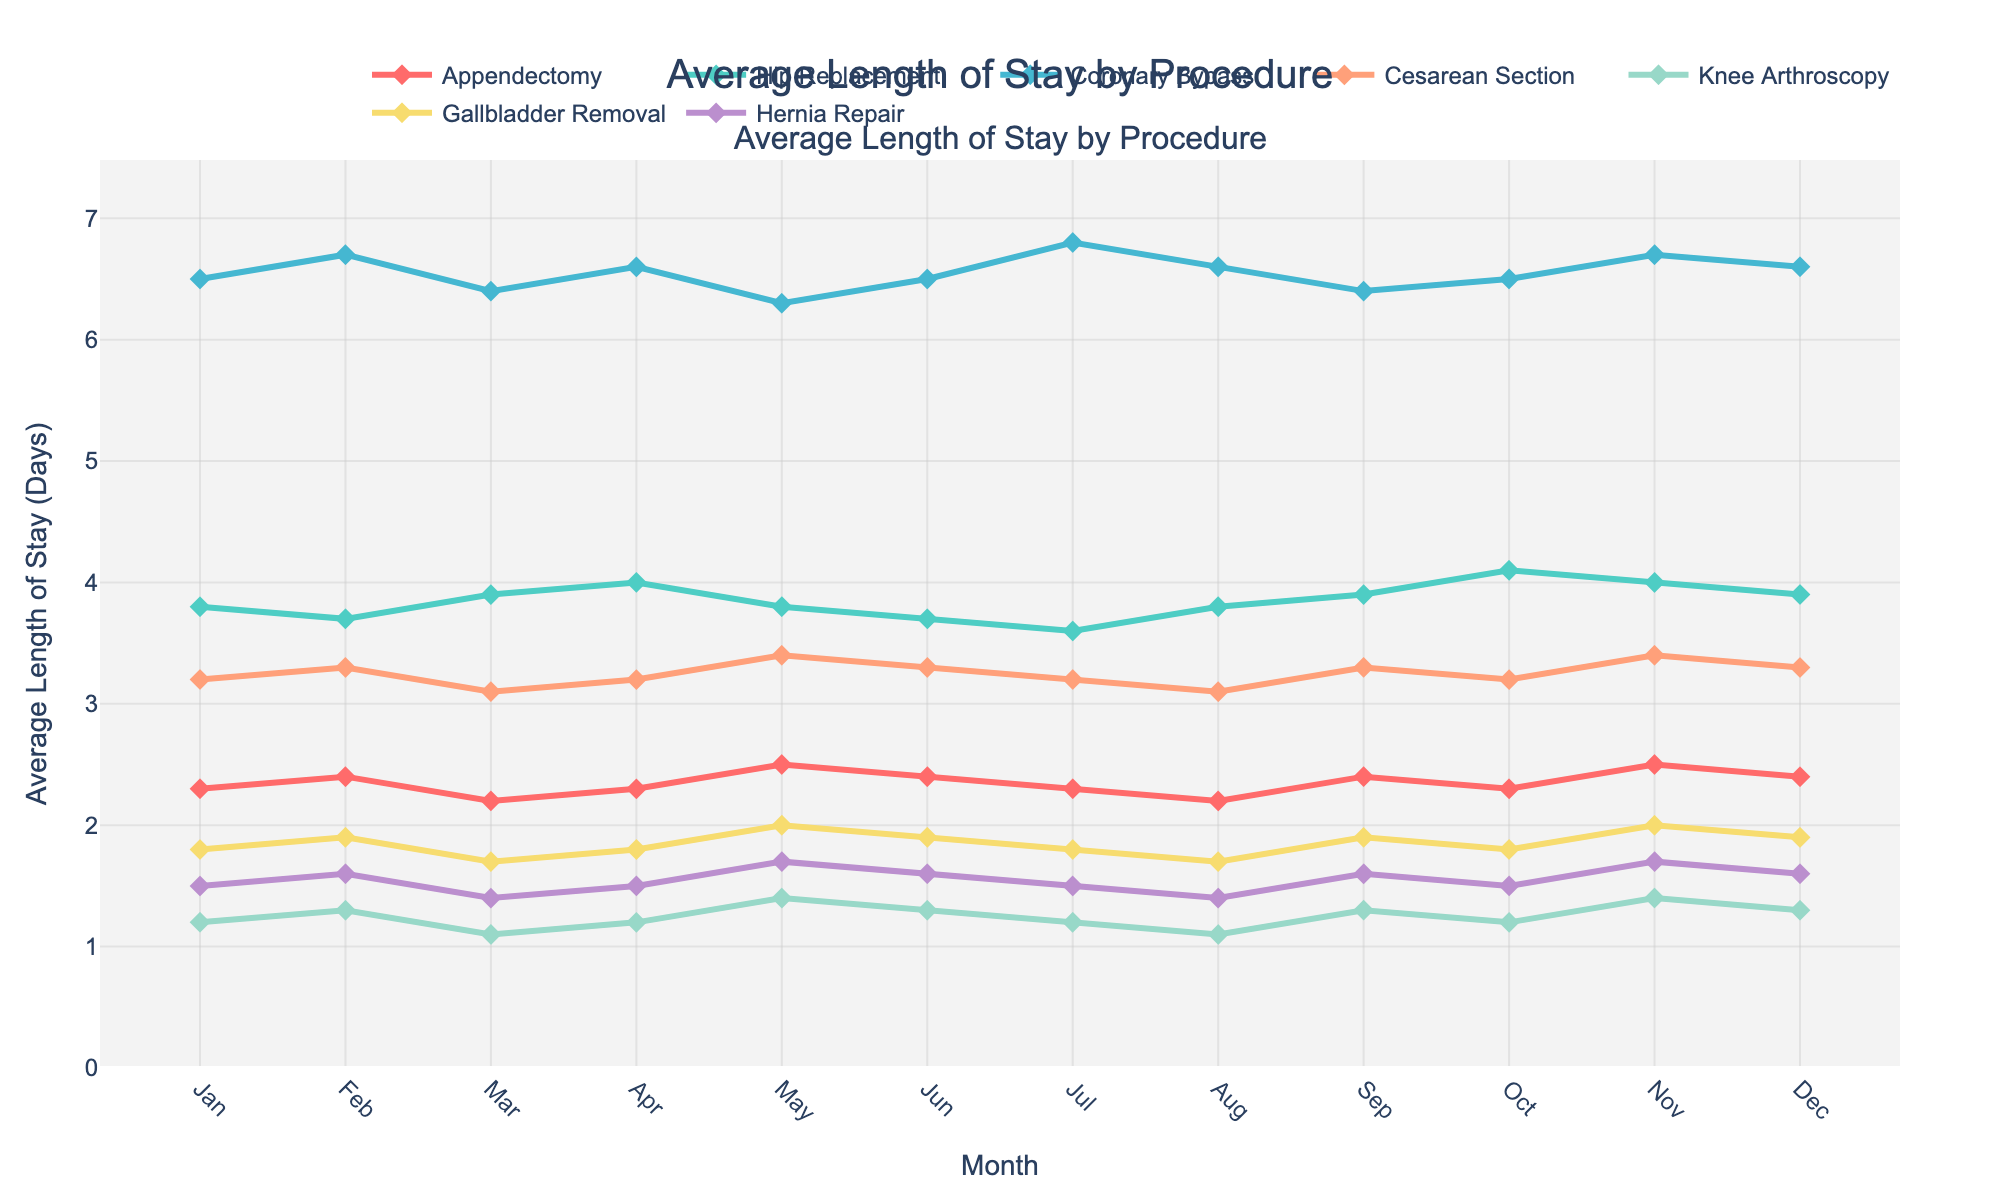What is the average length of stay for Hip Replacement in July? Find the data point for Hip Replacement in July on the chart.
Answer: 3.6 days Between Gallbladder Removal and Hernia Repair in June, which has a longer average length of stay? Look at the June data points for Gallbladder Removal and Hernia Repair and compare them. Gallbladder Removal has 1.9 days, and Hernia Repair has 1.6 days.
Answer: Gallbladder Removal Which procedure has the highest average length of stay in March? Identify the March data point for each procedure and find the highest value.
Answer: Coronary Bypass By how much did the average length of stay for Appendectomy change from January to December? Subtract the January value from the December value for Appendectomy. 2.4 - 2.3 = 0.1 day.
Answer: 0.1 day What is the overall trend for Cesarean Section from January to December? Observe the data points for Cesarean Section from January to December. The trend fluctuates but generally remains stable with slight increases and decreases.
Answer: Stable How many procedures have their highest monthly average length of stay in May? For each procedure, check the May value and compare it with values of all other months to find if it’s the highest.
Answer: Two (Appendectomy and Knee Arthroscopy) Is there any month where all procedures have lower average length of stay than in the previous month? For each month, compare the average length of stay for all procedures with the previous month.
Answer: No What is the difference between the highest and lowest average length of stay for Coronary Bypass across the year? Identify the highest (6.8 in July) and lowest (6.3 in May) values for Coronary Bypass and subtract them. 6.8 - 6.3 = 0.5 days.
Answer: 0.5 days Which procedure has the least variation in average length of stay throughout the year? Compare the range (difference between maximum and minimum values) for each procedure's average length of stay. Knee Arthroscopy varies between 1.1 and 1.4, which is the smallest range.
Answer: Knee Arthroscopy What’s the combined average length of stay for Hernia Repair in the first quarter of the year? Add the average length of stay of Hernia Repair for January, February, and March and then divide by 3. (1.5 + 1.6 + 1.4)/3 = 1.5 days.
Answer: 1.5 days 